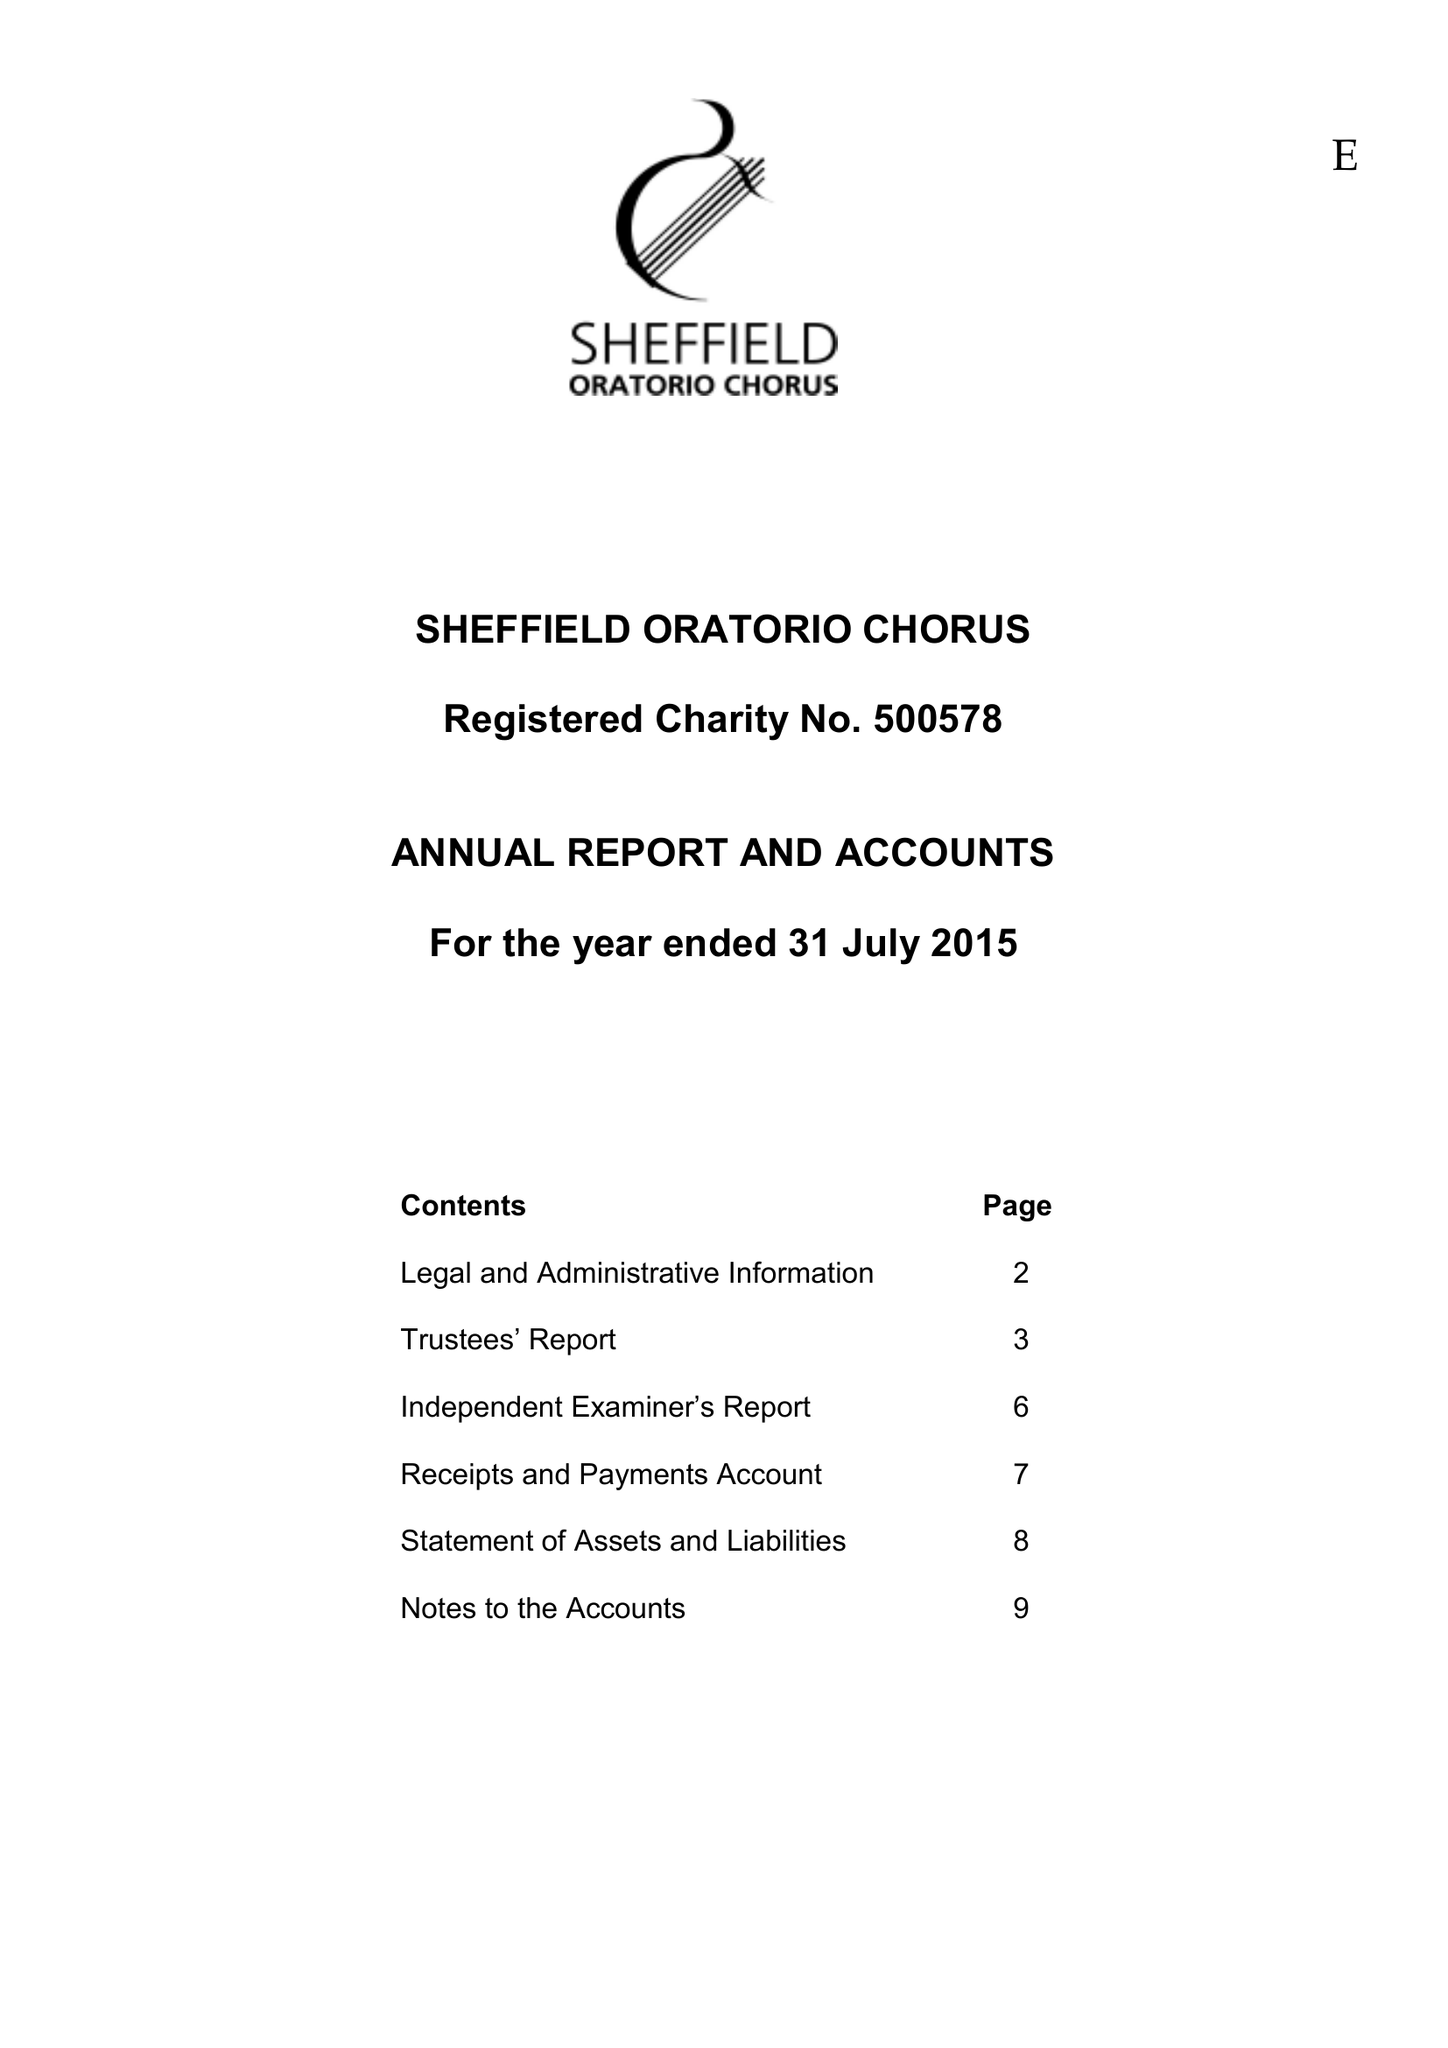What is the value for the address__postcode?
Answer the question using a single word or phrase. HD9 1SY 